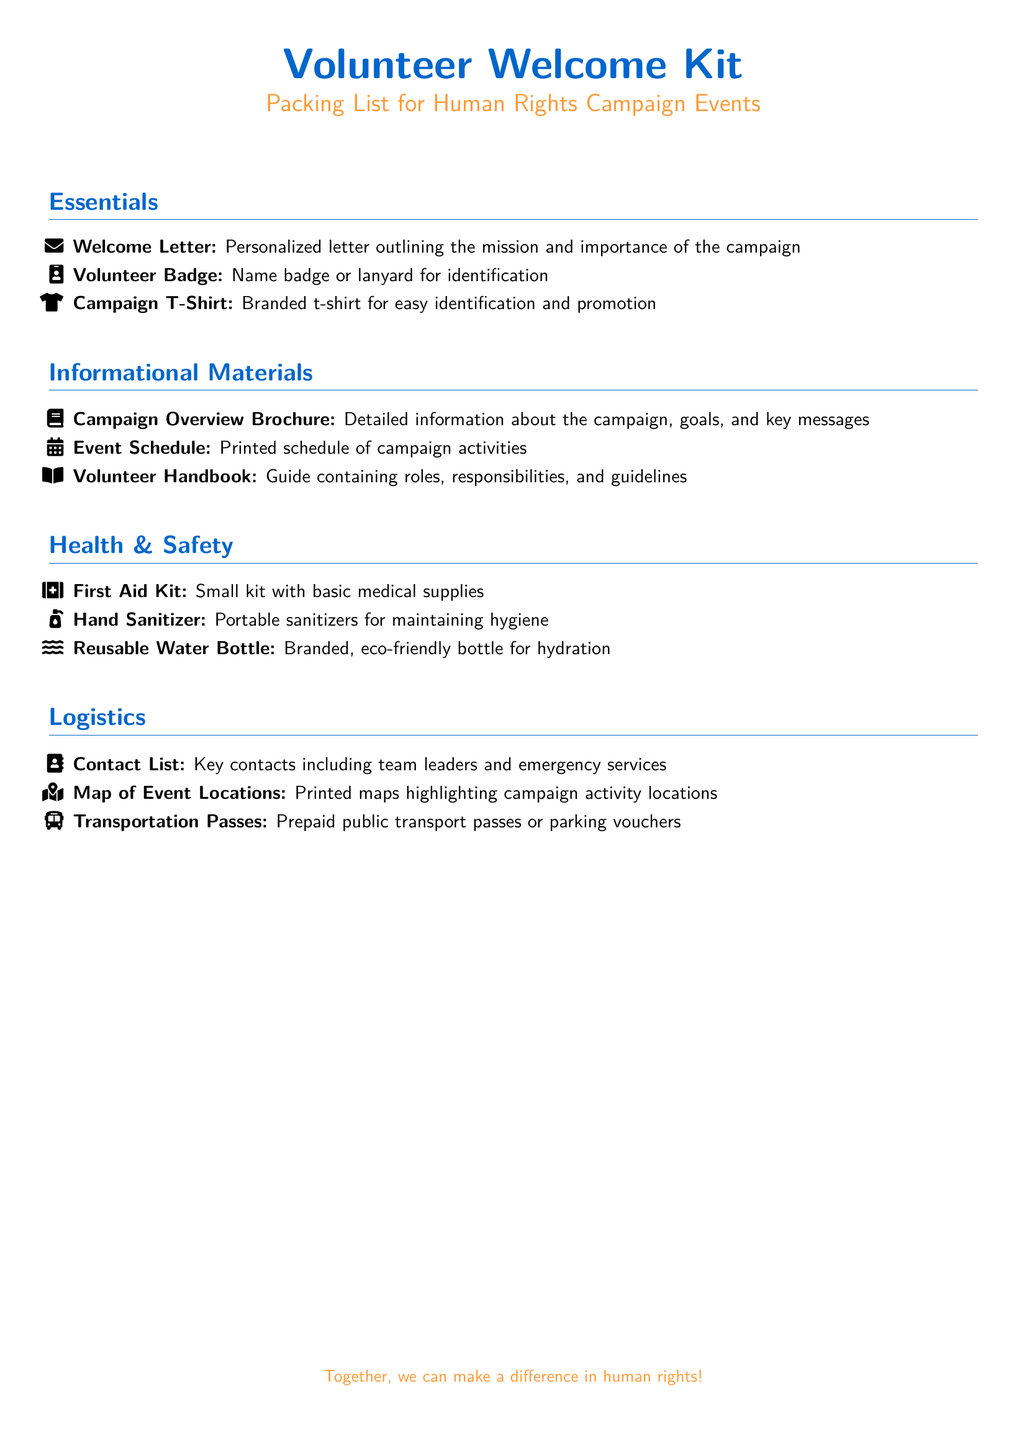What is the first item listed under Essentials? The first item under the Essentials section is the Welcome Letter, which outlines the mission and importance of the campaign.
Answer: Welcome Letter How many types of informational materials are listed? The document lists three types of informational materials: Campaign Overview Brochure, Event Schedule, and Volunteer Handbook.
Answer: Three What is included in the Health & Safety section? The Health & Safety section includes a First Aid Kit, Hand Sanitizer, and Reusable Water Bottle.
Answer: First Aid Kit, Hand Sanitizer, Reusable Water Bottle What type of contact information is provided in the Logistics section? The Logistics section provides a Contact List which includes key contacts such as team leaders and emergency services.
Answer: Contact List Why is a Reusable Water Bottle included in the kit? The Reusable Water Bottle is included for hydration and is branded and eco-friendly.
Answer: Hydration How many logistics items are mentioned in total? There are three logistics items mentioned: Contact List, Map of Event Locations, and Transportation Passes.
Answer: Three 